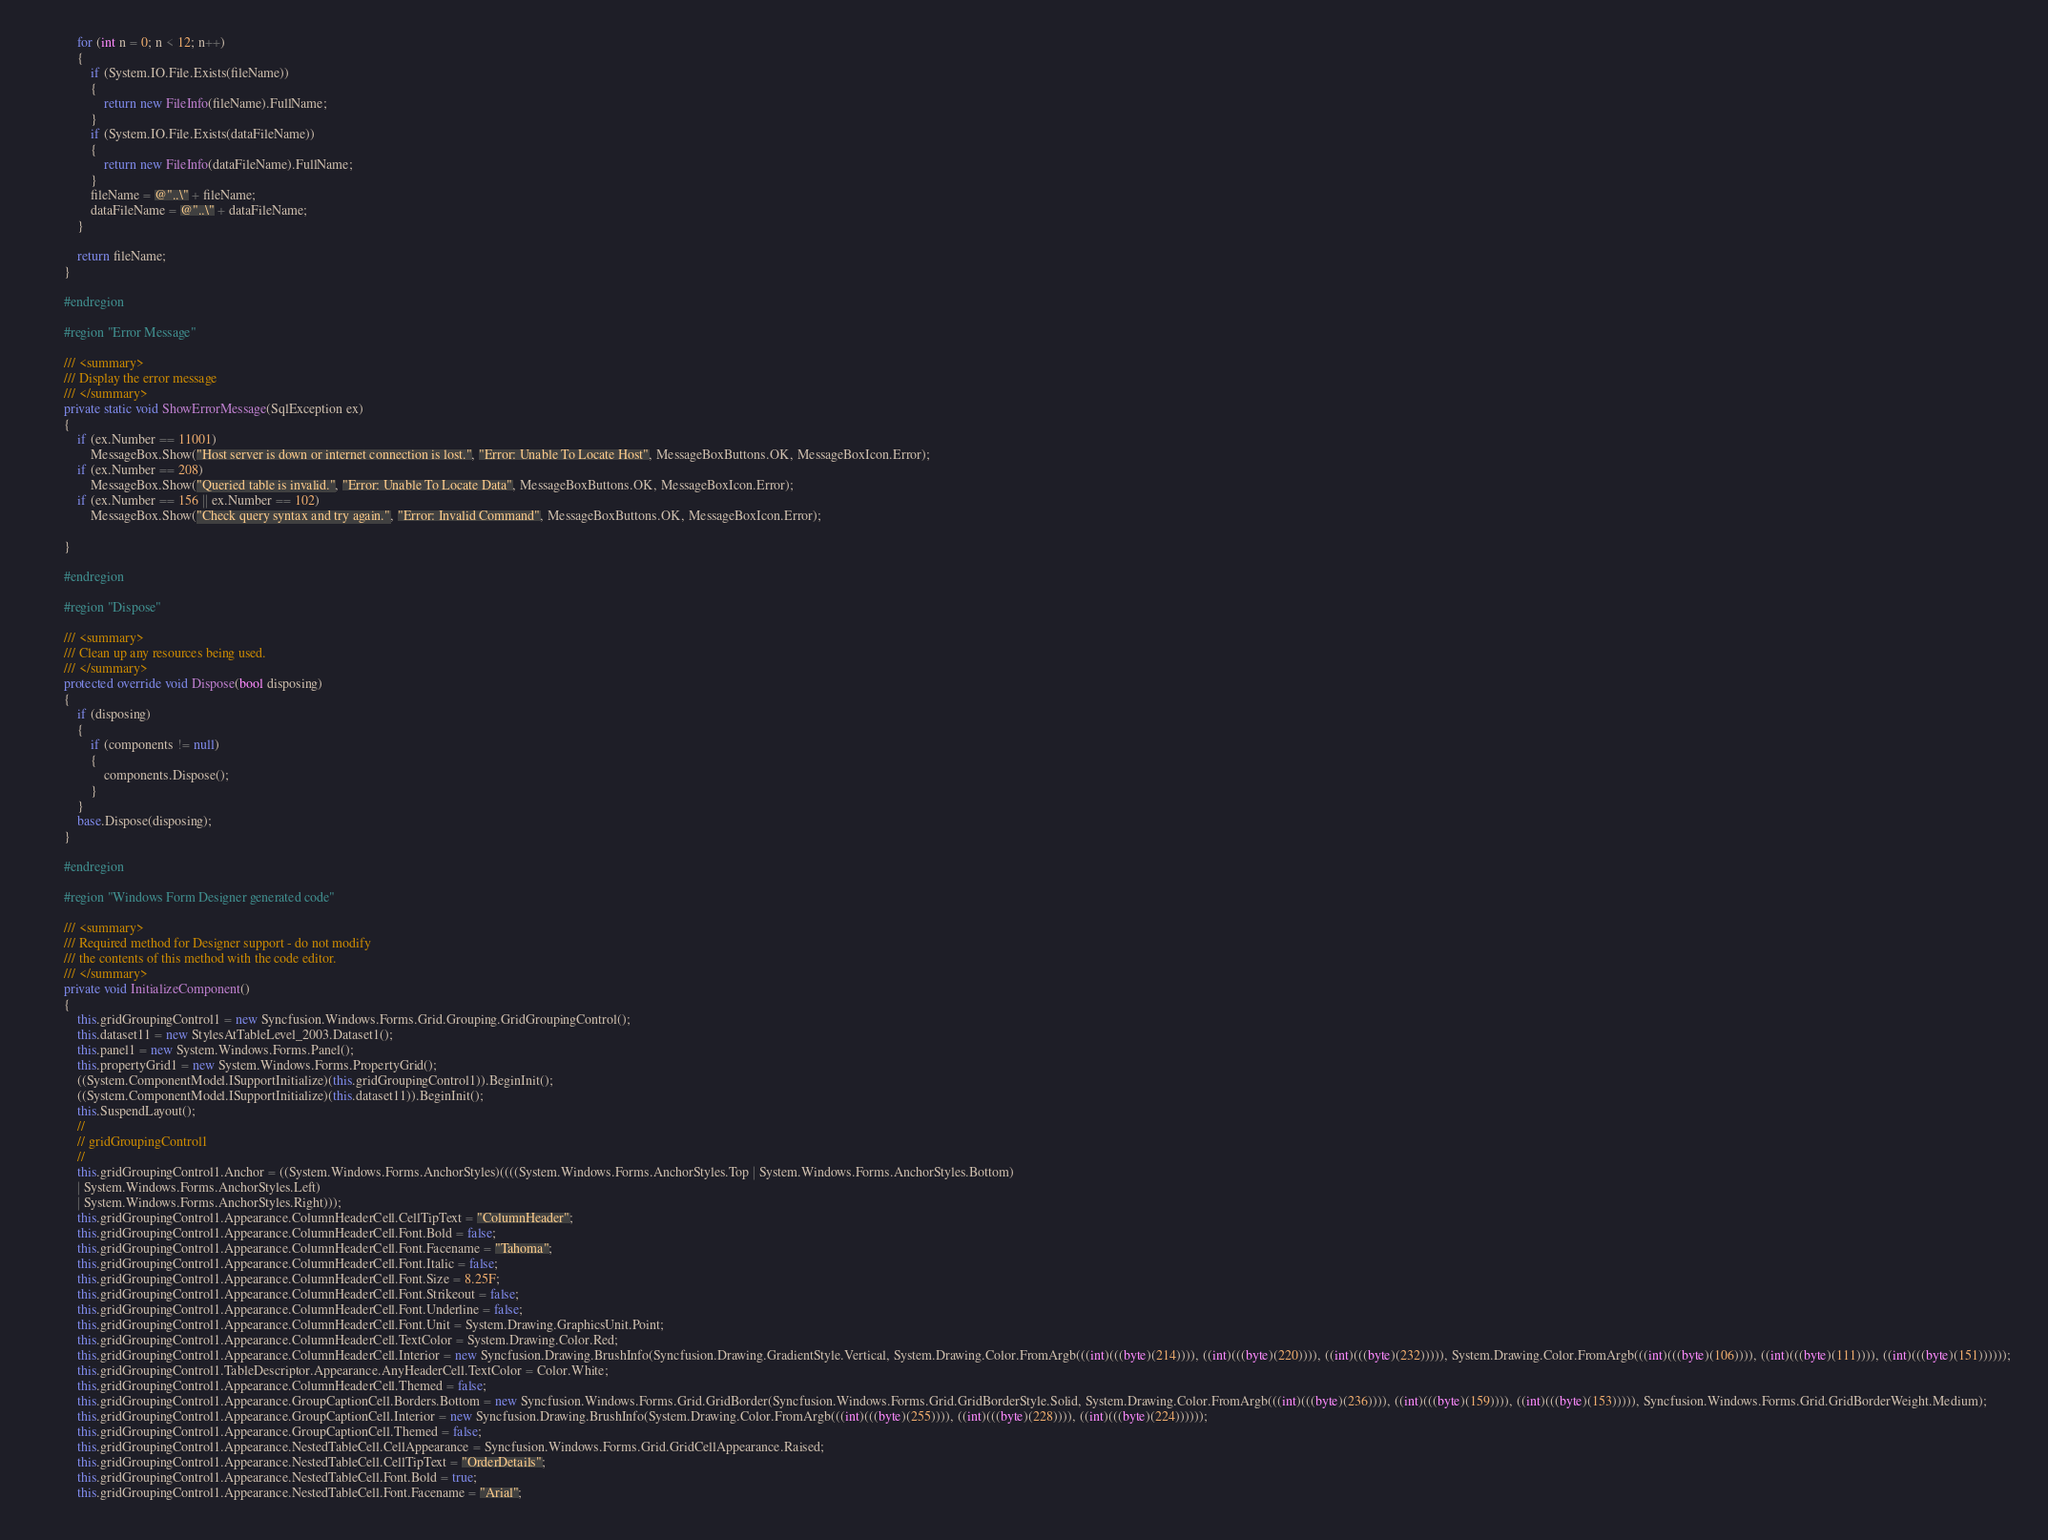<code> <loc_0><loc_0><loc_500><loc_500><_C#_>            for (int n = 0; n < 12; n++)
            {
                if (System.IO.File.Exists(fileName))
                {
                    return new FileInfo(fileName).FullName;
                }
                if (System.IO.File.Exists(dataFileName))
                {
                    return new FileInfo(dataFileName).FullName;
                }
                fileName = @"..\" + fileName;
                dataFileName = @"..\" + dataFileName;
            }

            return fileName;
        }

        #endregion

        #region "Error Message"

        /// <summary>
        /// Display the error message
        /// </summary>
        private static void ShowErrorMessage(SqlException ex)
        {
            if (ex.Number == 11001)
                MessageBox.Show("Host server is down or internet connection is lost.", "Error: Unable To Locate Host", MessageBoxButtons.OK, MessageBoxIcon.Error);
            if (ex.Number == 208)
                MessageBox.Show("Queried table is invalid.", "Error: Unable To Locate Data", MessageBoxButtons.OK, MessageBoxIcon.Error);
            if (ex.Number == 156 || ex.Number == 102)
                MessageBox.Show("Check query syntax and try again.", "Error: Invalid Command", MessageBoxButtons.OK, MessageBoxIcon.Error);

        }

        #endregion

        #region "Dispose"

        /// <summary>
        /// Clean up any resources being used.
        /// </summary>
        protected override void Dispose(bool disposing)
        {
            if (disposing)
            {
                if (components != null)
                {
                    components.Dispose();
                }
            }
            base.Dispose(disposing);
        }

        #endregion

        #region "Windows Form Designer generated code"

        /// <summary>
        /// Required method for Designer support - do not modify
        /// the contents of this method with the code editor.
        /// </summary>
        private void InitializeComponent()
        {
            this.gridGroupingControl1 = new Syncfusion.Windows.Forms.Grid.Grouping.GridGroupingControl();
            this.dataset11 = new StylesAtTableLevel_2003.Dataset1();
            this.panel1 = new System.Windows.Forms.Panel();
            this.propertyGrid1 = new System.Windows.Forms.PropertyGrid();
            ((System.ComponentModel.ISupportInitialize)(this.gridGroupingControl1)).BeginInit();
            ((System.ComponentModel.ISupportInitialize)(this.dataset11)).BeginInit();
            this.SuspendLayout();
            // 
            // gridGroupingControl1
            // 
            this.gridGroupingControl1.Anchor = ((System.Windows.Forms.AnchorStyles)((((System.Windows.Forms.AnchorStyles.Top | System.Windows.Forms.AnchorStyles.Bottom) 
            | System.Windows.Forms.AnchorStyles.Left) 
            | System.Windows.Forms.AnchorStyles.Right)));
            this.gridGroupingControl1.Appearance.ColumnHeaderCell.CellTipText = "ColumnHeader";
            this.gridGroupingControl1.Appearance.ColumnHeaderCell.Font.Bold = false;
            this.gridGroupingControl1.Appearance.ColumnHeaderCell.Font.Facename = "Tahoma";
            this.gridGroupingControl1.Appearance.ColumnHeaderCell.Font.Italic = false;
            this.gridGroupingControl1.Appearance.ColumnHeaderCell.Font.Size = 8.25F;
            this.gridGroupingControl1.Appearance.ColumnHeaderCell.Font.Strikeout = false;
            this.gridGroupingControl1.Appearance.ColumnHeaderCell.Font.Underline = false;
            this.gridGroupingControl1.Appearance.ColumnHeaderCell.Font.Unit = System.Drawing.GraphicsUnit.Point;
            this.gridGroupingControl1.Appearance.ColumnHeaderCell.TextColor = System.Drawing.Color.Red;
            this.gridGroupingControl1.Appearance.ColumnHeaderCell.Interior = new Syncfusion.Drawing.BrushInfo(Syncfusion.Drawing.GradientStyle.Vertical, System.Drawing.Color.FromArgb(((int)(((byte)(214)))), ((int)(((byte)(220)))), ((int)(((byte)(232))))), System.Drawing.Color.FromArgb(((int)(((byte)(106)))), ((int)(((byte)(111)))), ((int)(((byte)(151))))));
            this.gridGroupingControl1.TableDescriptor.Appearance.AnyHeaderCell.TextColor = Color.White;
            this.gridGroupingControl1.Appearance.ColumnHeaderCell.Themed = false;
            this.gridGroupingControl1.Appearance.GroupCaptionCell.Borders.Bottom = new Syncfusion.Windows.Forms.Grid.GridBorder(Syncfusion.Windows.Forms.Grid.GridBorderStyle.Solid, System.Drawing.Color.FromArgb(((int)(((byte)(236)))), ((int)(((byte)(159)))), ((int)(((byte)(153))))), Syncfusion.Windows.Forms.Grid.GridBorderWeight.Medium);
            this.gridGroupingControl1.Appearance.GroupCaptionCell.Interior = new Syncfusion.Drawing.BrushInfo(System.Drawing.Color.FromArgb(((int)(((byte)(255)))), ((int)(((byte)(228)))), ((int)(((byte)(224))))));
            this.gridGroupingControl1.Appearance.GroupCaptionCell.Themed = false;
            this.gridGroupingControl1.Appearance.NestedTableCell.CellAppearance = Syncfusion.Windows.Forms.Grid.GridCellAppearance.Raised;
            this.gridGroupingControl1.Appearance.NestedTableCell.CellTipText = "OrderDetails";
            this.gridGroupingControl1.Appearance.NestedTableCell.Font.Bold = true;
            this.gridGroupingControl1.Appearance.NestedTableCell.Font.Facename = "Arial";</code> 